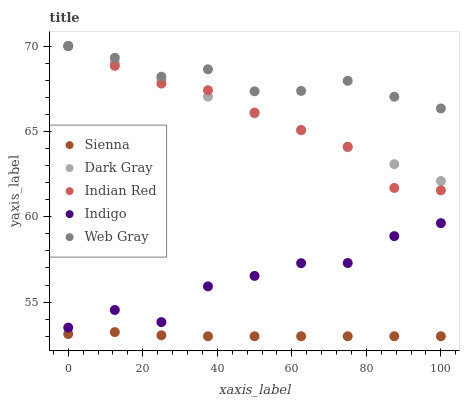Does Sienna have the minimum area under the curve?
Answer yes or no. Yes. Does Web Gray have the maximum area under the curve?
Answer yes or no. Yes. Does Dark Gray have the minimum area under the curve?
Answer yes or no. No. Does Dark Gray have the maximum area under the curve?
Answer yes or no. No. Is Dark Gray the smoothest?
Answer yes or no. Yes. Is Indigo the roughest?
Answer yes or no. Yes. Is Web Gray the smoothest?
Answer yes or no. No. Is Web Gray the roughest?
Answer yes or no. No. Does Sienna have the lowest value?
Answer yes or no. Yes. Does Dark Gray have the lowest value?
Answer yes or no. No. Does Indian Red have the highest value?
Answer yes or no. Yes. Does Indigo have the highest value?
Answer yes or no. No. Is Sienna less than Dark Gray?
Answer yes or no. Yes. Is Indian Red greater than Indigo?
Answer yes or no. Yes. Does Indian Red intersect Dark Gray?
Answer yes or no. Yes. Is Indian Red less than Dark Gray?
Answer yes or no. No. Is Indian Red greater than Dark Gray?
Answer yes or no. No. Does Sienna intersect Dark Gray?
Answer yes or no. No. 